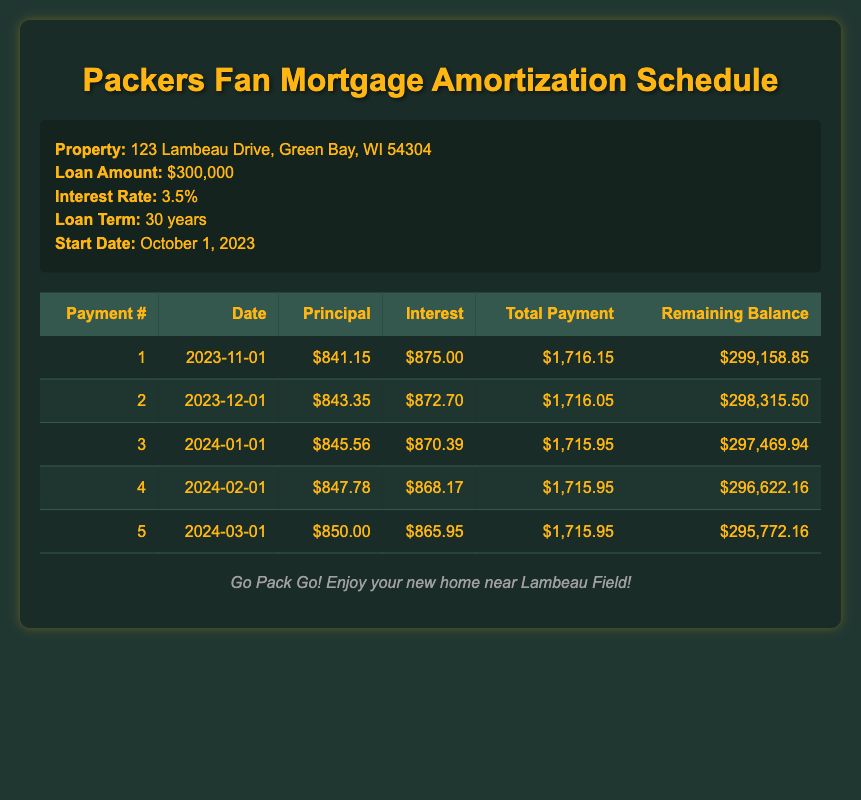What is the total payment for the first month? In the first row of the schedule, the total payment is listed as 1716.15.
Answer: 1716.15 How much will be paid toward the principal in the second month? In the second row, the principal payment is 843.35.
Answer: 843.35 Is the interest payment decreasing from the first month to the second month? The interest payment for the first month is 875.00 and for the second month is 872.70. Since 872.70 is less than 875.00, the interest payment is decreasing.
Answer: Yes What is the remaining balance after the third payment? After the third payment, the remaining balance is shown as 297469.94 in the third row.
Answer: 297469.94 What is the average principal payment for the first five months? The principal payments for the first five months are 841.15, 843.35, 845.56, 847.78, and 850.00. To find the average, sum the amounts to get 428.84 and divide by 5, yielding an average principal payment of 845.77.
Answer: 845.77 How much total interest is paid in the first five payments? The total interest for the first five months is 875.00 + 872.70 + 870.39 + 868.17 + 865.95, which sums to 4352.21.
Answer: 4352.21 Is the total payment for the fourth month the same as the total payment for the fifth month? The total payment for the fourth month is 1715.95 and for the fifth month it is also 1715.95, hence they are the same.
Answer: Yes What is the principal payment increase from the first month to the fifth month? The principal payment in the first month is 841.15 and in the fifth month is 850.00. The increase in principal payment is calculated as 850.00 - 841.15 = 8.85.
Answer: 8.85 After the first payment, how much of the total payment goes toward interest in the first month? The total payment in the first month is 1716.15, and the interest payment is 875.00. Therefore, the portion that goes toward interest is the interest payment divided by the total payment: 875.00 / 1716.15, giving approximately 0.51 or 51%.
Answer: Approximately 51% 